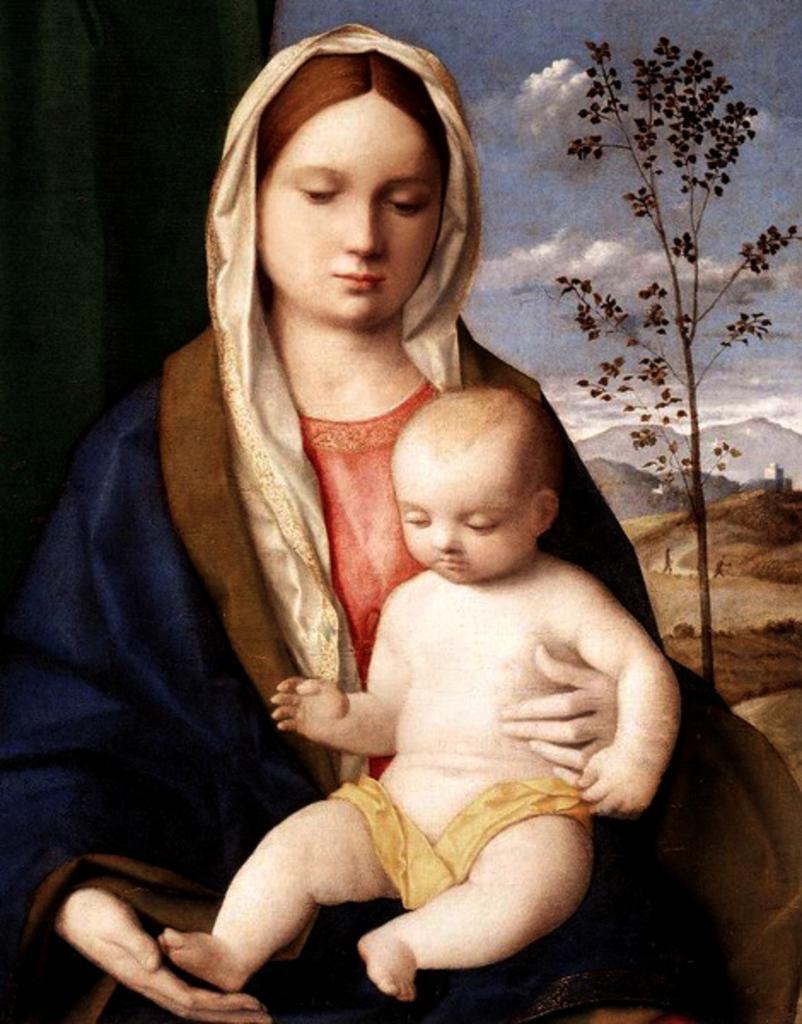In one or two sentences, can you explain what this image depicts? This pictures seems to be a painting. In the foreground there is a woman sitting on the chair and holding a baby. In the background there is sky, tree, hills and some persons seems to be walking on the ground. 